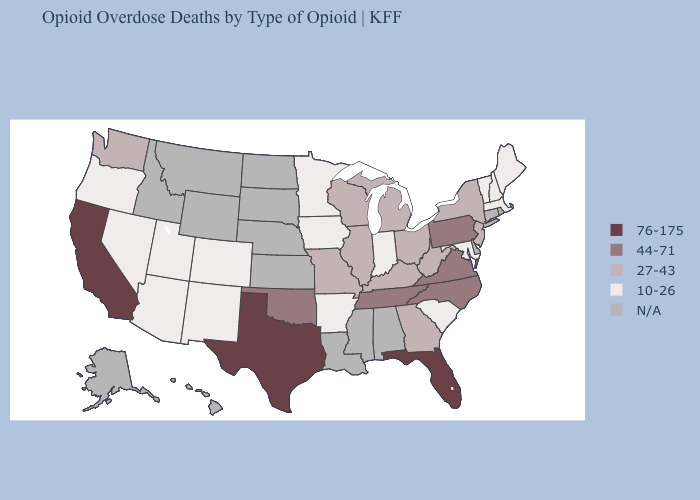Which states have the lowest value in the South?
Answer briefly. Arkansas, Maryland, South Carolina. Among the states that border New York , does Pennsylvania have the highest value?
Quick response, please. Yes. Name the states that have a value in the range 76-175?
Write a very short answer. California, Florida, Texas. Among the states that border Colorado , which have the lowest value?
Quick response, please. Arizona, New Mexico, Utah. Does Colorado have the lowest value in the USA?
Keep it brief. Yes. What is the value of New York?
Be succinct. 27-43. What is the value of Maryland?
Give a very brief answer. 10-26. What is the value of Louisiana?
Be succinct. N/A. What is the value of California?
Quick response, please. 76-175. Name the states that have a value in the range 10-26?
Give a very brief answer. Arizona, Arkansas, Colorado, Indiana, Iowa, Maine, Maryland, Massachusetts, Minnesota, Nevada, New Hampshire, New Mexico, Oregon, South Carolina, Utah, Vermont. Is the legend a continuous bar?
Quick response, please. No. Name the states that have a value in the range 10-26?
Write a very short answer. Arizona, Arkansas, Colorado, Indiana, Iowa, Maine, Maryland, Massachusetts, Minnesota, Nevada, New Hampshire, New Mexico, Oregon, South Carolina, Utah, Vermont. Does Florida have the highest value in the USA?
Be succinct. Yes. Name the states that have a value in the range 44-71?
Keep it brief. North Carolina, Oklahoma, Pennsylvania, Tennessee, Virginia. Name the states that have a value in the range 27-43?
Quick response, please. Georgia, Illinois, Kentucky, Michigan, Missouri, New Jersey, New York, Ohio, Washington, West Virginia, Wisconsin. 